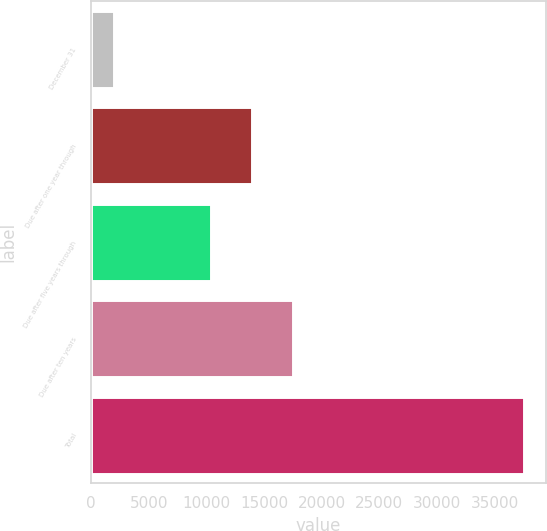Convert chart. <chart><loc_0><loc_0><loc_500><loc_500><bar_chart><fcel>December 31<fcel>Due after one year through<fcel>Due after five years through<fcel>Due after ten years<fcel>Total<nl><fcel>2010<fcel>13994.3<fcel>10437<fcel>17551.6<fcel>37583<nl></chart> 